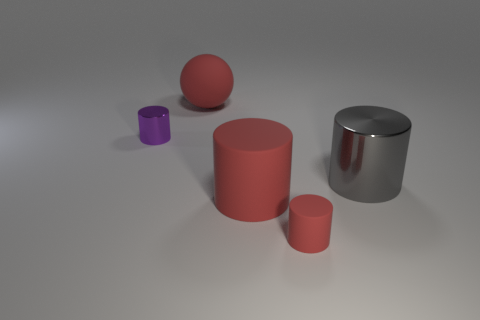Add 2 small rubber objects. How many objects exist? 7 Subtract all gray cylinders. How many cylinders are left? 3 Subtract 3 cylinders. How many cylinders are left? 1 Subtract all spheres. How many objects are left? 4 Subtract all cyan cubes. How many cyan spheres are left? 0 Subtract all large blue rubber cubes. Subtract all tiny purple cylinders. How many objects are left? 4 Add 5 small red rubber things. How many small red rubber things are left? 6 Add 5 cyan spheres. How many cyan spheres exist? 5 Subtract 0 cyan blocks. How many objects are left? 5 Subtract all cyan cylinders. Subtract all green cubes. How many cylinders are left? 4 